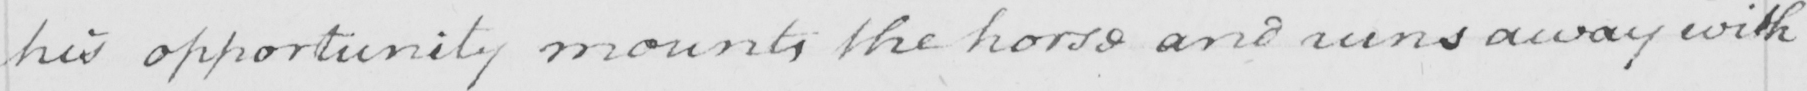Transcribe the text shown in this historical manuscript line. his opportunity mounts the horse and runs away with 